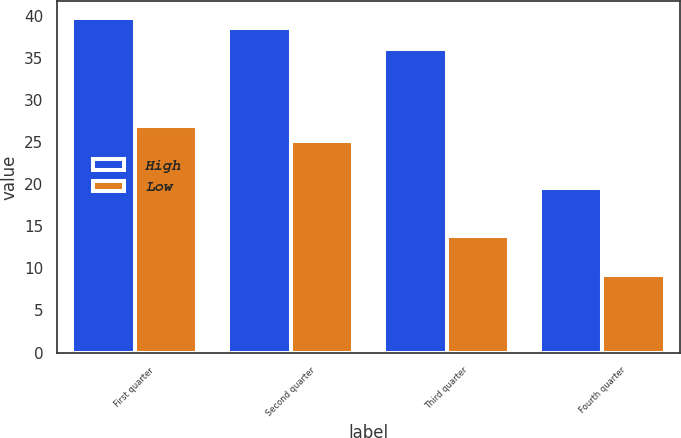<chart> <loc_0><loc_0><loc_500><loc_500><stacked_bar_chart><ecel><fcel>First quarter<fcel>Second quarter<fcel>Third quarter<fcel>Fourth quarter<nl><fcel>High<fcel>39.77<fcel>38.62<fcel>36.07<fcel>19.6<nl><fcel>Low<fcel>26.9<fcel>25.17<fcel>13.85<fcel>9.25<nl></chart> 